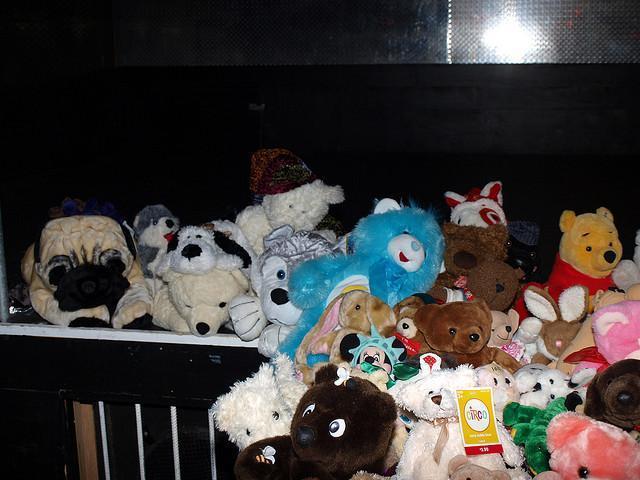How many teddy bears are visible?
Give a very brief answer. 11. How many orange trucks are there?
Give a very brief answer. 0. 